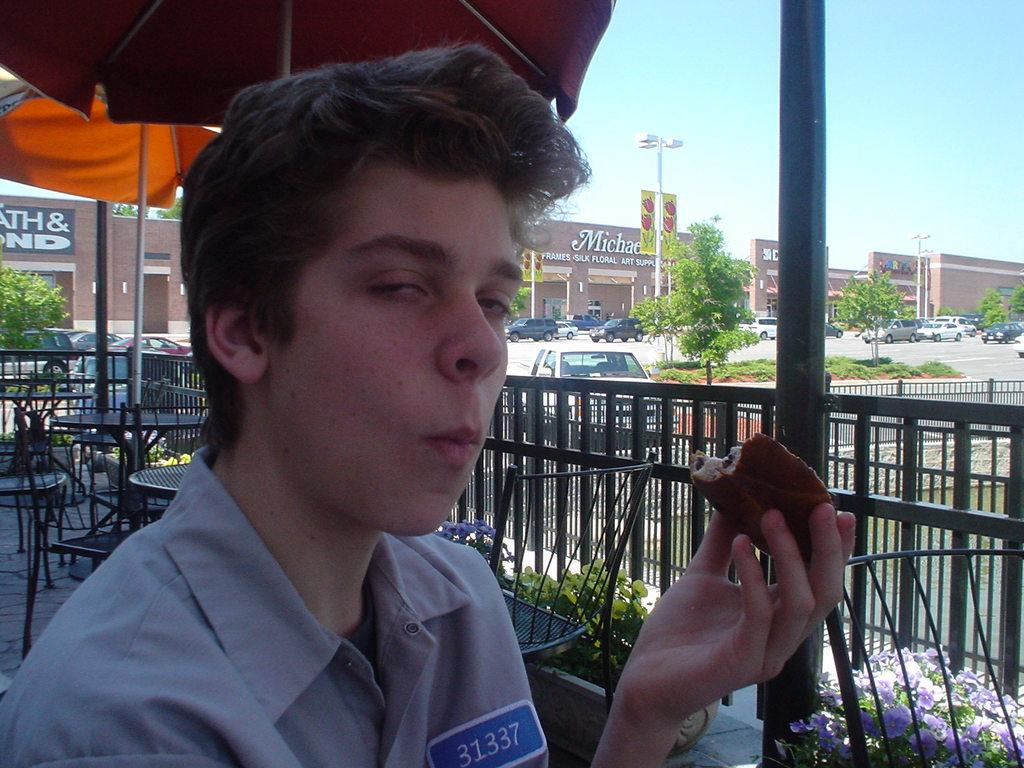<image>
Create a compact narrative representing the image presented. a man wearing a number 31337 uniform holding a bread 